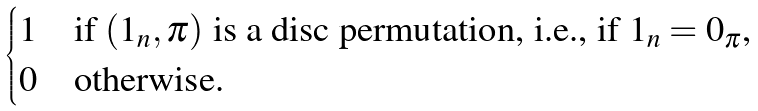Convert formula to latex. <formula><loc_0><loc_0><loc_500><loc_500>\begin{cases} 1 & \text {if $(1_{n},\pi)$ is a disc permutation, i.e., if $1_{n}=0_{\pi}$,} \\ 0 & \text {otherwise.} \end{cases}</formula> 